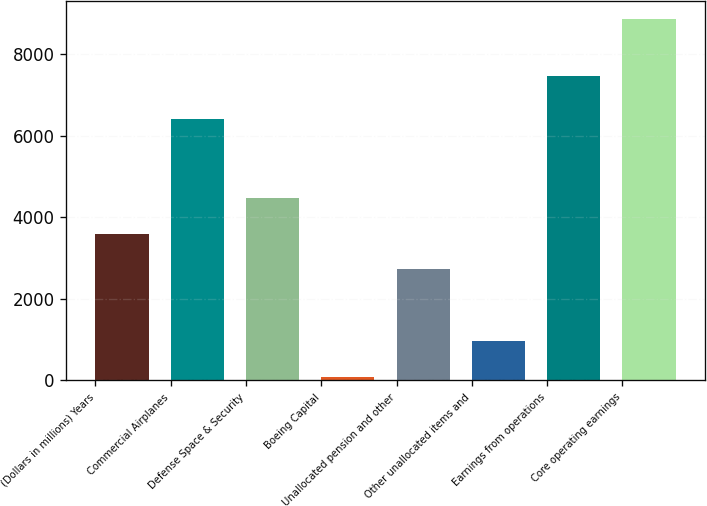Convert chart to OTSL. <chart><loc_0><loc_0><loc_500><loc_500><bar_chart><fcel>(Dollars in millions) Years<fcel>Commercial Airplanes<fcel>Defense Space & Security<fcel>Boeing Capital<fcel>Unallocated pension and other<fcel>Other unallocated items and<fcel>Earnings from operations<fcel>Core operating earnings<nl><fcel>3599.2<fcel>6411<fcel>4476<fcel>92<fcel>2722.4<fcel>968.8<fcel>7473<fcel>8860<nl></chart> 